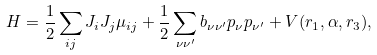<formula> <loc_0><loc_0><loc_500><loc_500>H = \frac { 1 } { 2 } \sum _ { i j } J _ { i } J _ { j } \mu _ { i j } + \frac { 1 } { 2 } \sum _ { \nu \nu ^ { \prime } } b _ { \nu \nu ^ { \prime } } p _ { \nu } p _ { \nu ^ { \prime } } + V ( r _ { 1 } , \alpha , r _ { 3 } ) ,</formula> 